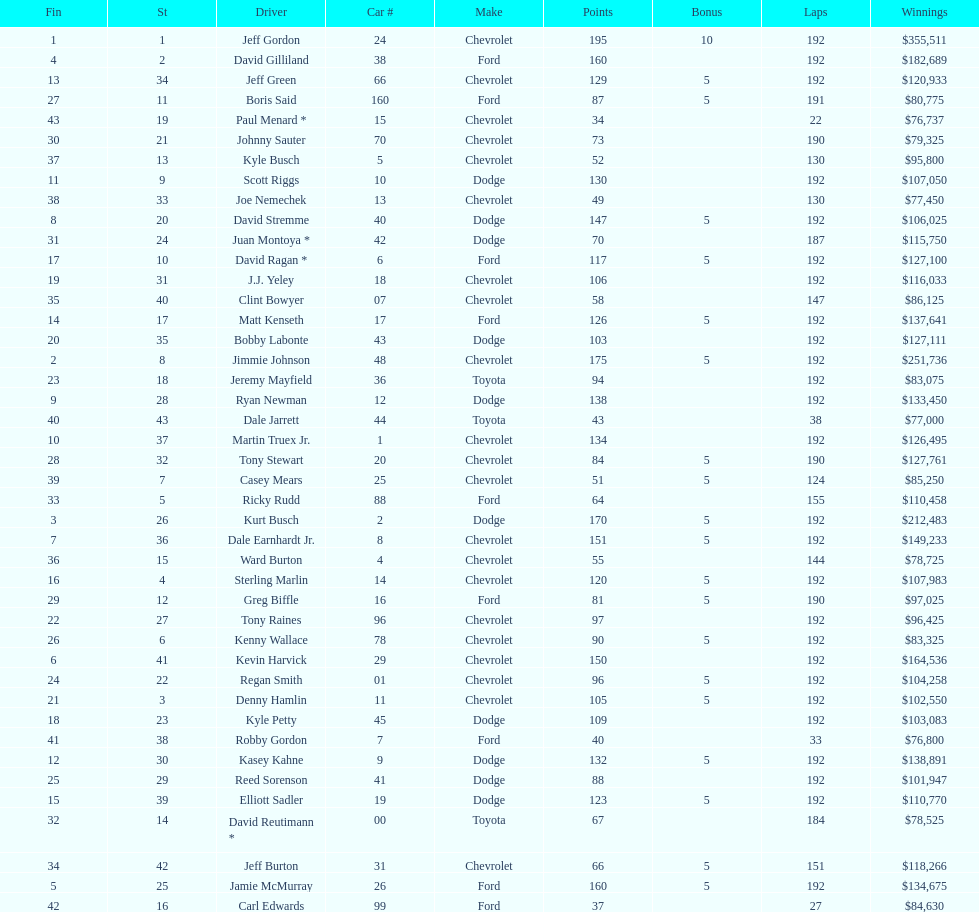Who is first in number of winnings on this list? Jeff Gordon. 